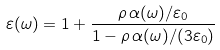Convert formula to latex. <formula><loc_0><loc_0><loc_500><loc_500>\varepsilon ( \omega ) = 1 + \frac { \rho \, \alpha ( \omega ) / \varepsilon _ { 0 } } { 1 - \rho \, \alpha ( \omega ) / ( 3 \varepsilon _ { 0 } ) }</formula> 